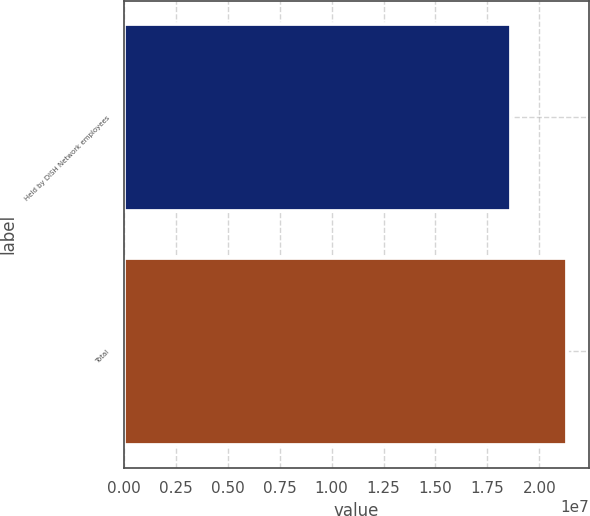Convert chart to OTSL. <chart><loc_0><loc_0><loc_500><loc_500><bar_chart><fcel>Held by DISH Network employees<fcel>Total<nl><fcel>1.86304e+07<fcel>2.13362e+07<nl></chart> 